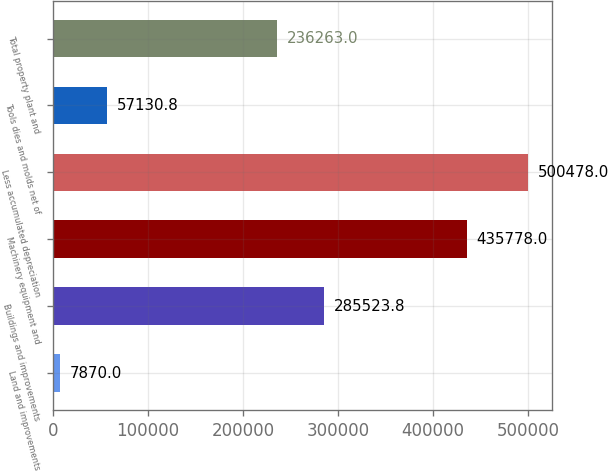Convert chart to OTSL. <chart><loc_0><loc_0><loc_500><loc_500><bar_chart><fcel>Land and improvements<fcel>Buildings and improvements<fcel>Machinery equipment and<fcel>Less accumulated depreciation<fcel>Tools dies and molds net of<fcel>Total property plant and<nl><fcel>7870<fcel>285524<fcel>435778<fcel>500478<fcel>57130.8<fcel>236263<nl></chart> 